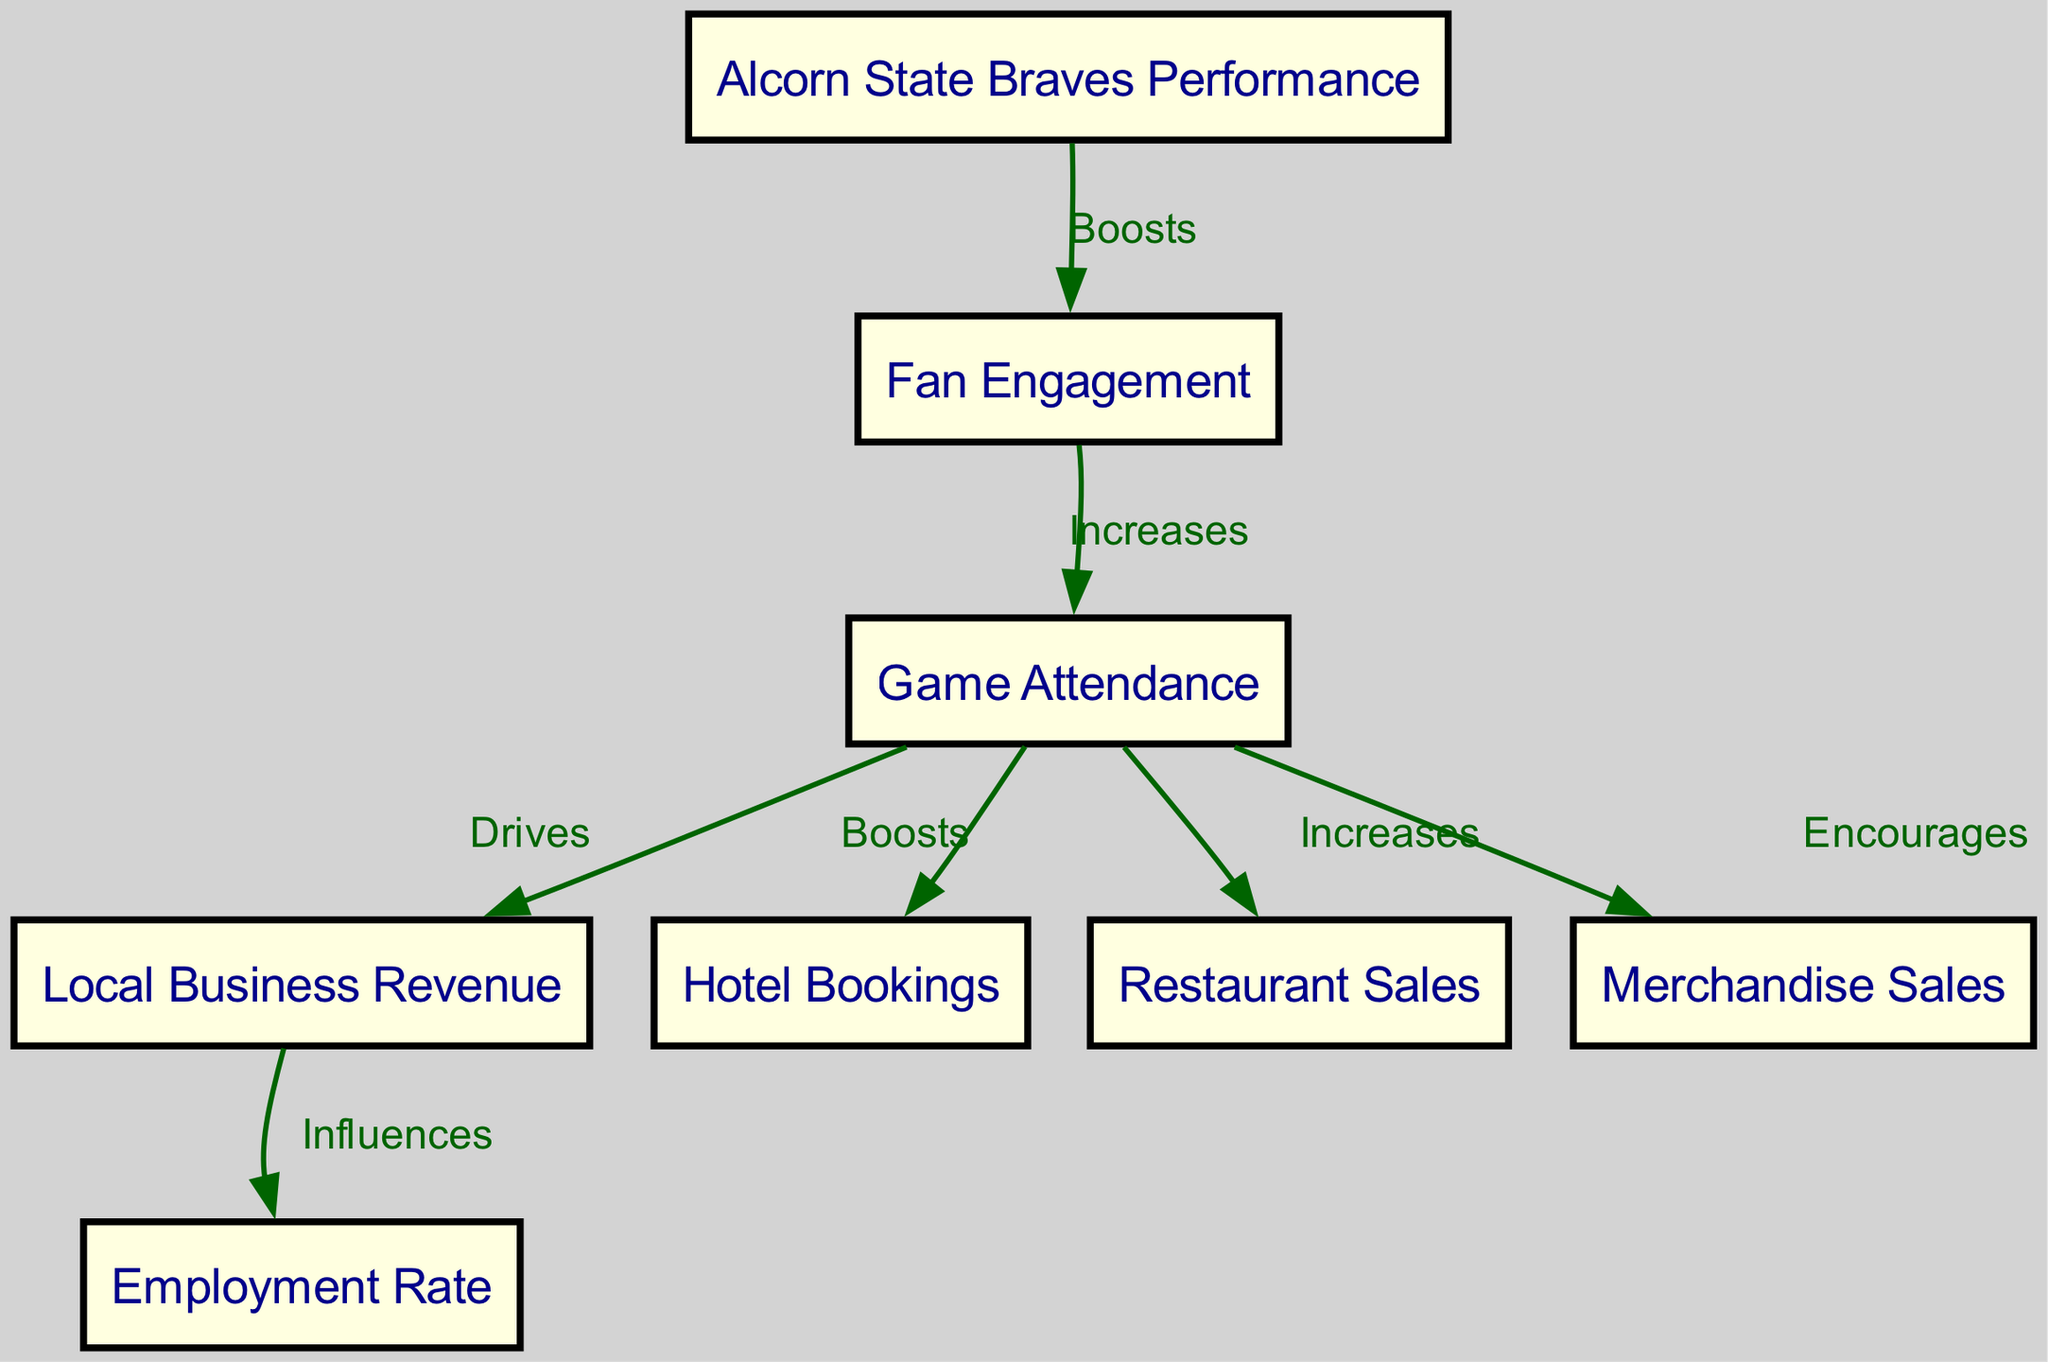What is the total number of nodes in the diagram? The diagram lists 8 nodes that represent different aspects of the socioeconomic impact of college football, such as team performance and business revenues.
Answer: 8 What does "fan engagement" increase? From the diagram, it clearly states that fan engagement increases game attendance, which is a direct relationship between these two nodes.
Answer: Game Attendance Which node is influenced by local business revenue? According to the diagram, local business revenue influences the employment rate, indicating a flow of impact from one to the other.
Answer: Employment Rate How does game attendance impact local business revenue? The diagram indicates that game attendance drives local business revenue, showing a causal connection between these two factors in the socioeconomic context.
Answer: Drives What do hotel bookings increase as a result of? The diagram shows that hotel bookings are boosted by game attendance, indicating that higher attendance leads to more hotel stays in the local area.
Answer: Game Attendance Which connection indicates that merchandise sales are encouraged? The diagram presents merchandise sales as being encouraged by game attendance, illustrating a link between attendance at games and sales of team merchandise.
Answer: Game Attendance What label is associated with the relationship between football team performance and fan engagement? The diagram specifies that the relationship between football team performance and fan engagement is described as "boosts," indicating a supportive connection.
Answer: Boosts What economic effect does game attendance have on restaurant sales? The diagram indicates that game attendance increases restaurant sales, establishing a direct connection between attendance figures and sales at local dining establishments.
Answer: Increases 